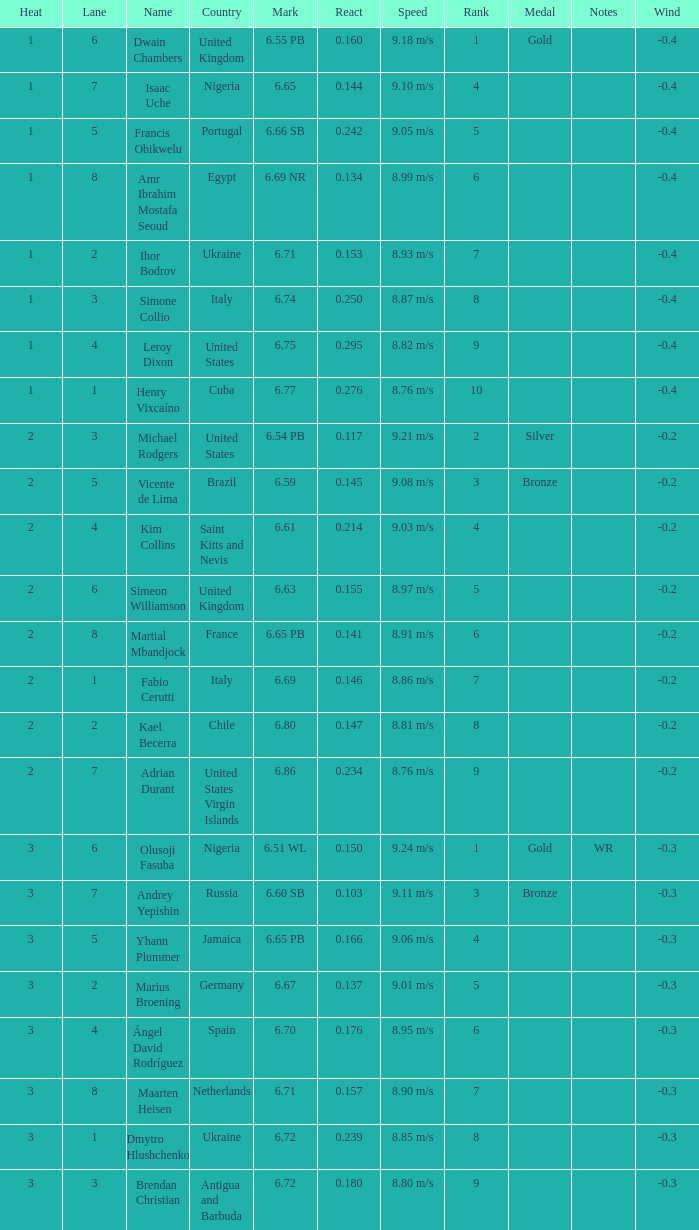When mark equals 6.69, what is the meaning of heat? 2.0. 